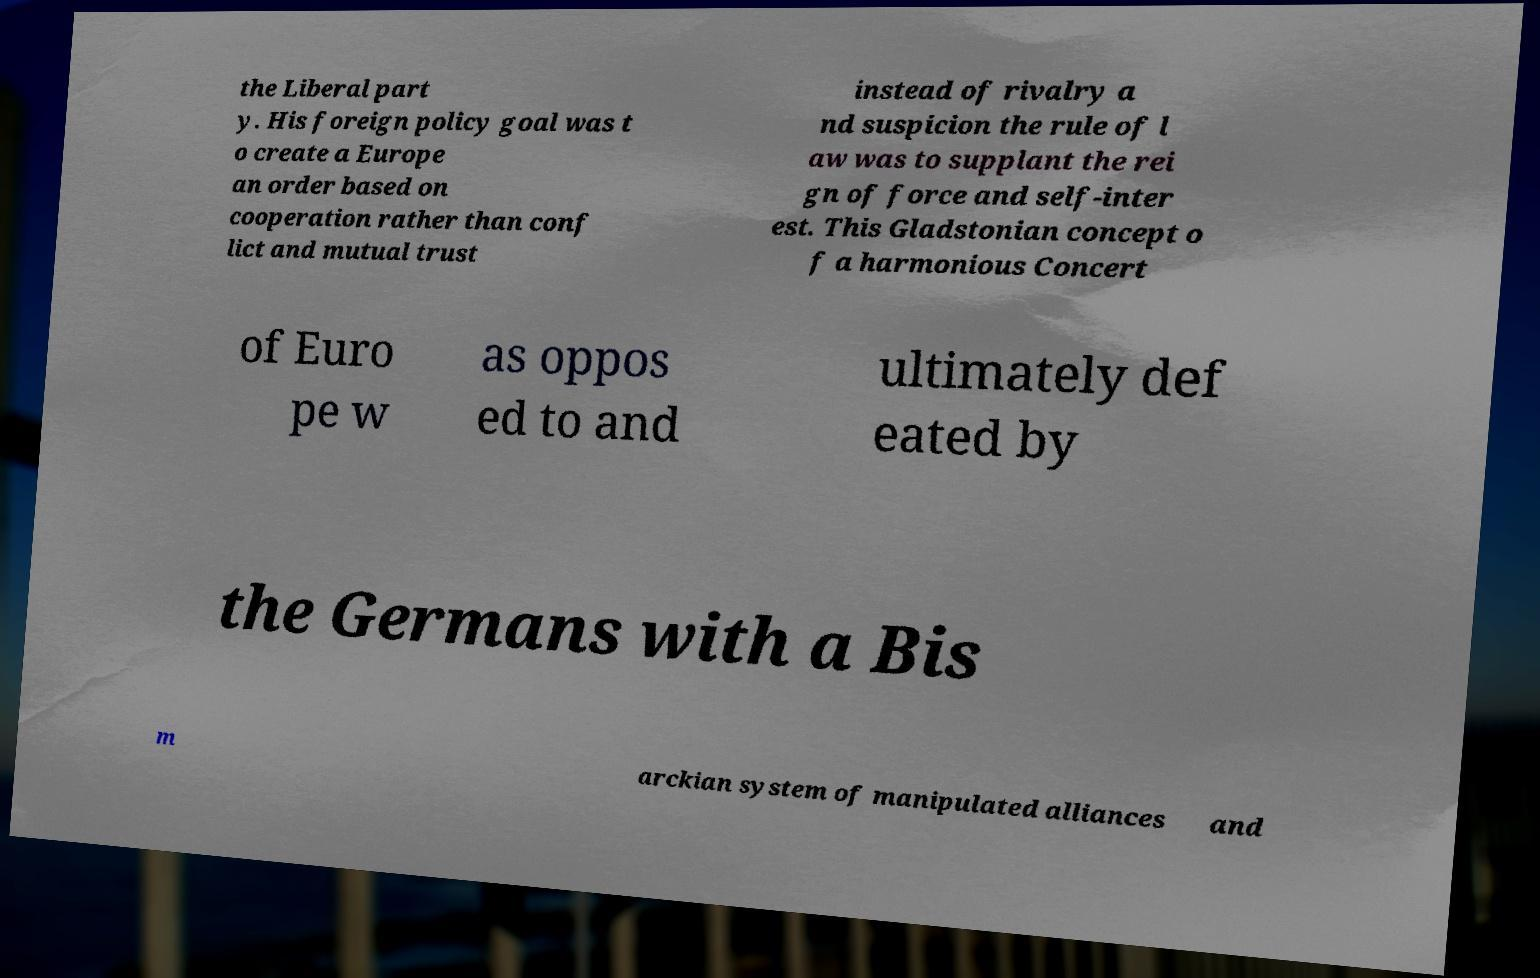For documentation purposes, I need the text within this image transcribed. Could you provide that? the Liberal part y. His foreign policy goal was t o create a Europe an order based on cooperation rather than conf lict and mutual trust instead of rivalry a nd suspicion the rule of l aw was to supplant the rei gn of force and self-inter est. This Gladstonian concept o f a harmonious Concert of Euro pe w as oppos ed to and ultimately def eated by the Germans with a Bis m arckian system of manipulated alliances and 